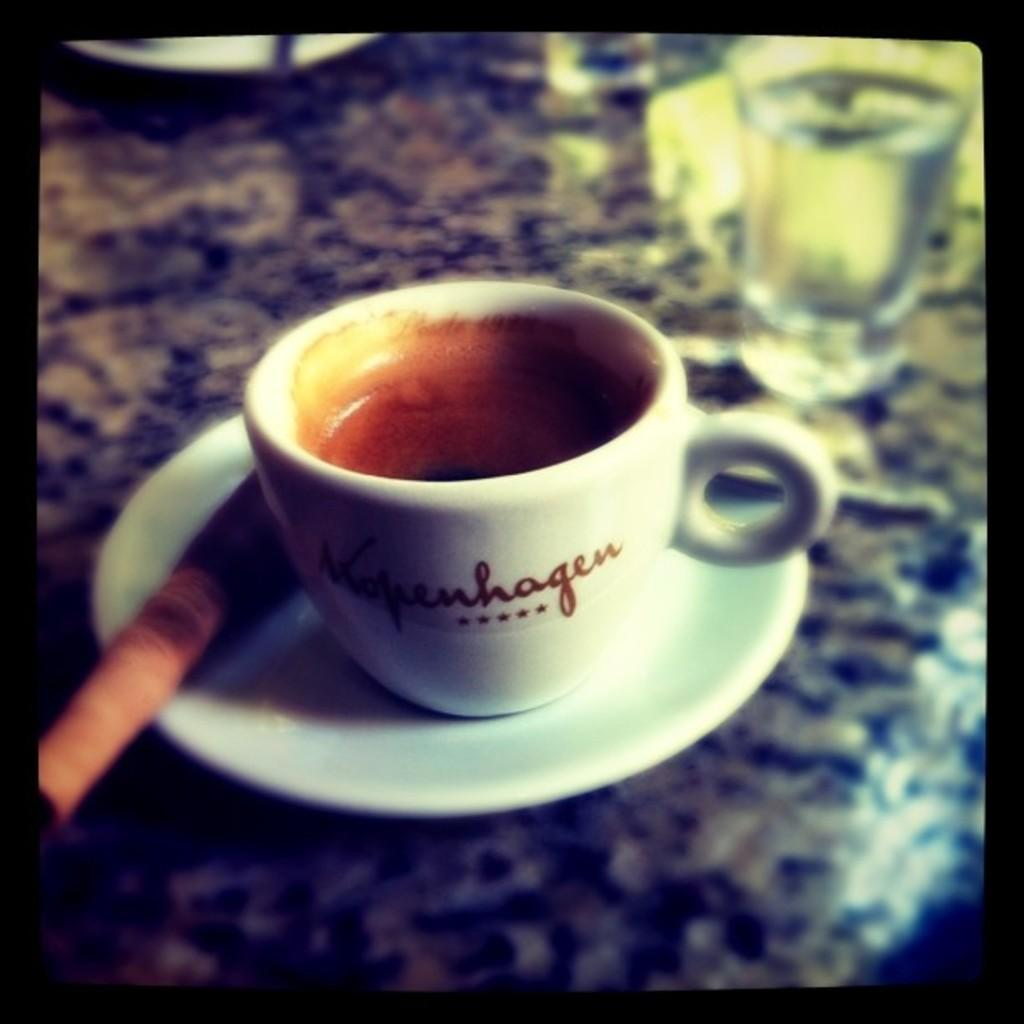What type of dishware is visible in the image? There is a cup and saucer in the image. What else can be seen in the image besides the cup and saucer? There is a glass with water in the image. Where are the objects located in the image? The objects are on a surface. Are there any fairies flying around the cup and saucer in the image? No, there are no fairies present in the image. What type of school is depicted in the image? There is no school depicted in the image; it features a cup, saucer, and glass with water on a surface. 